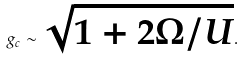<formula> <loc_0><loc_0><loc_500><loc_500>g _ { c } \sim \sqrt { 1 + 2 \Omega / U } .</formula> 